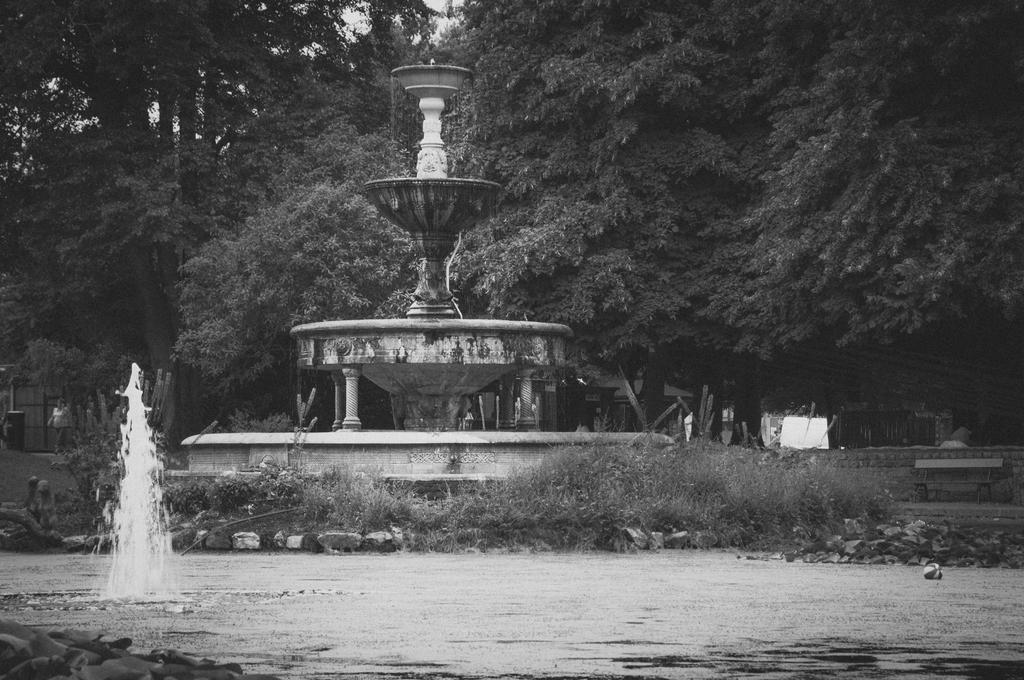Please provide a concise description of this image. In this image in the foreground there is water body. In the background there are trees, monument. Few people are walking here. Here there are stone. 